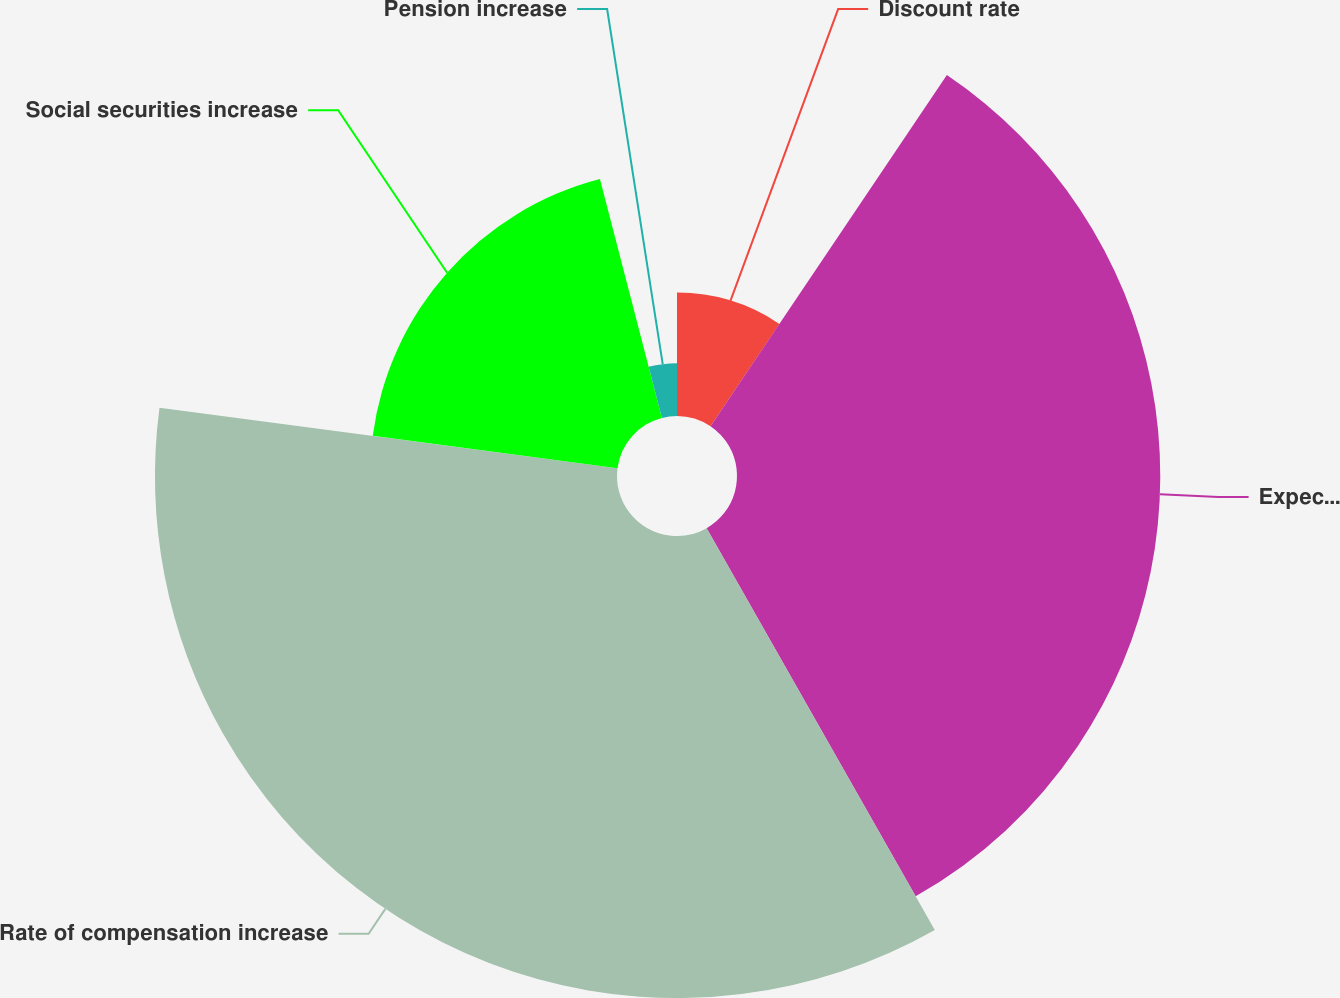<chart> <loc_0><loc_0><loc_500><loc_500><pie_chart><fcel>Discount rate<fcel>Expected return on plan assets<fcel>Rate of compensation increase<fcel>Social securities increase<fcel>Pension increase<nl><fcel>9.43%<fcel>32.35%<fcel>35.31%<fcel>18.87%<fcel>4.04%<nl></chart> 